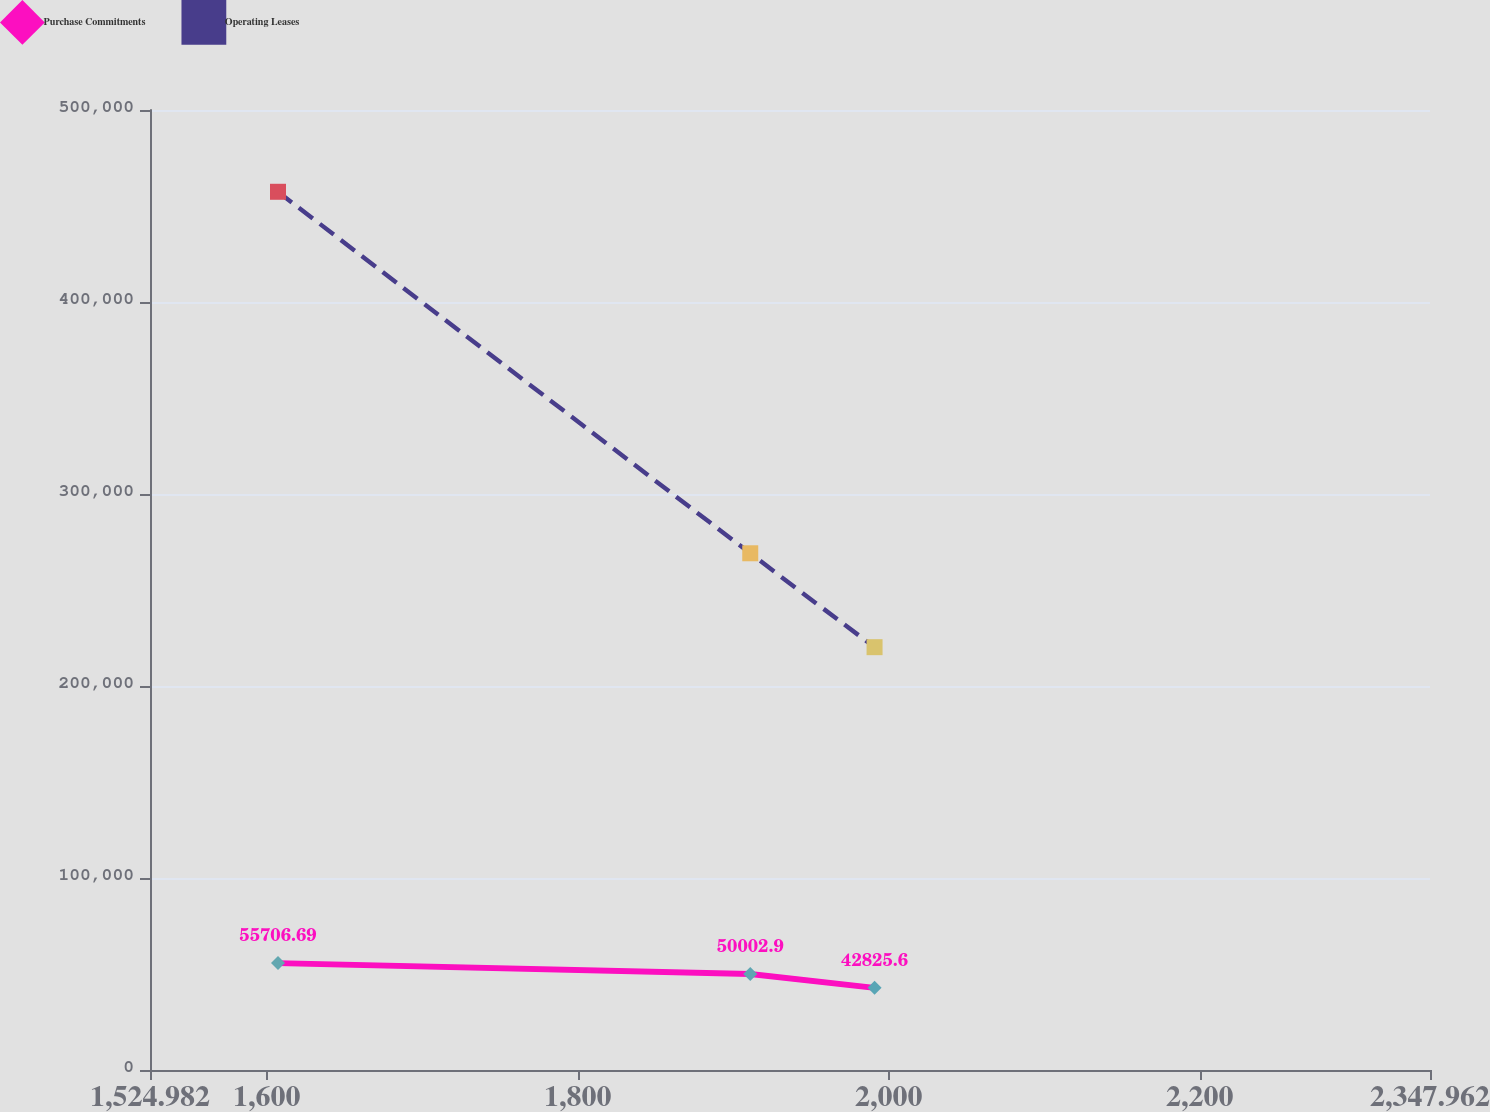<chart> <loc_0><loc_0><loc_500><loc_500><line_chart><ecel><fcel>Purchase Commitments<fcel>Operating Leases<nl><fcel>1607.28<fcel>55706.7<fcel>457408<nl><fcel>1910.91<fcel>50002.9<fcel>269128<nl><fcel>1990.84<fcel>42825.6<fcel>220221<nl><fcel>2350.33<fcel>39984.4<fcel>58716.9<nl><fcel>2430.26<fcel>31231<fcel>98586<nl></chart> 